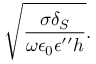Convert formula to latex. <formula><loc_0><loc_0><loc_500><loc_500>\sqrt { \frac { \sigma \delta _ { S } } { \omega \epsilon _ { 0 } \epsilon ^ { \prime \prime } h } } .</formula> 